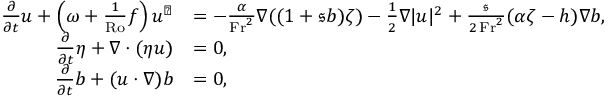<formula> <loc_0><loc_0><loc_500><loc_500>\begin{array} { r l } { \frac { \partial } { \partial t } u + \left ( \omega + \frac { 1 } { R o } f \right ) u ^ { \perp } } & { = - \frac { \alpha } { F r ^ { 2 } } \nabla ( ( 1 + \mathfrak { s } b ) \zeta ) - \frac { 1 } { 2 } \nabla | u | ^ { 2 } + \frac { \mathfrak { s } } { 2 \, F r ^ { 2 } } ( \alpha \zeta - h ) \nabla b , } \\ { \frac { \partial } { \partial t } \eta + \nabla \cdot ( \eta u ) } & { = 0 , } \\ { \frac { \partial } { \partial t } b + ( u \cdot \nabla ) b } & { = 0 , } \end{array}</formula> 